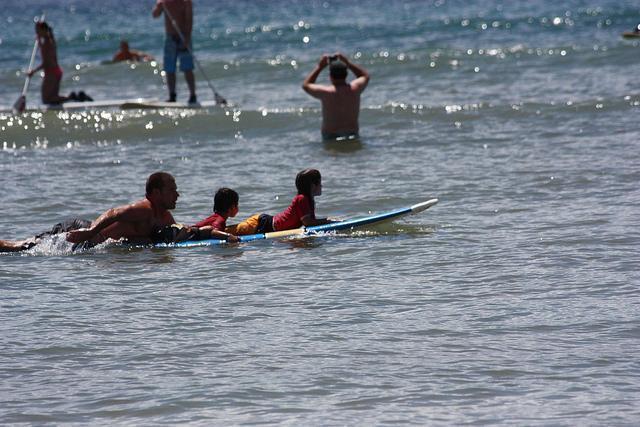What do the persons on boards here wish for?
Select the accurate response from the four choices given to answer the question.
Options: Chocolate sundaes, calm water, big waves, doldrums. Big waves. 